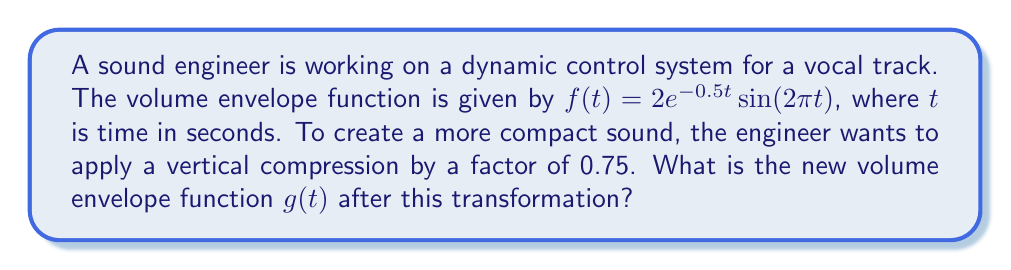Provide a solution to this math problem. To apply a vertical compression to a function, we multiply the entire function by the compression factor. In this case, the compression factor is 0.75.

Given:
- Original function: $f(t) = 2e^{-0.5t}\sin(2\pi t)$
- Compression factor: 0.75

Steps:
1. Multiply the entire function by the compression factor:
   $g(t) = 0.75 \cdot f(t)$

2. Substitute the original function:
   $g(t) = 0.75 \cdot (2e^{-0.5t}\sin(2\pi t))$

3. Simplify:
   $g(t) = (0.75 \cdot 2) \cdot e^{-0.5t}\sin(2\pi t)$
   $g(t) = 1.5e^{-0.5t}\sin(2\pi t)$

The new function $g(t)$ represents the vertically compressed volume envelope function, which will create a more compact sound for the vocal track while maintaining the overall shape and timing of the original envelope.
Answer: $g(t) = 1.5e^{-0.5t}\sin(2\pi t)$ 